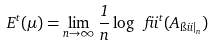Convert formula to latex. <formula><loc_0><loc_0><loc_500><loc_500>E ^ { t } ( \mu ) = \lim _ { n \to \infty } \frac { 1 } { n } \log \ f i i ^ { t } ( A _ { \i i i | _ { n } } )</formula> 